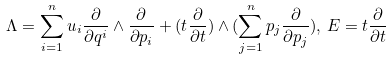Convert formula to latex. <formula><loc_0><loc_0><loc_500><loc_500>\Lambda = \sum _ { i = 1 } ^ { n } u _ { i } \frac { \partial } { \partial q ^ { i } } \wedge \frac { \partial } { \partial p _ { i } } + ( t \frac { \partial } { \partial t } ) \wedge ( \sum _ { j = 1 } ^ { n } p _ { j } \frac { \partial } { \partial p _ { j } } ) , \, E = t \frac { \partial } { \partial t }</formula> 